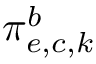<formula> <loc_0><loc_0><loc_500><loc_500>\pi _ { e , c , k } ^ { b }</formula> 